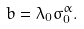Convert formula to latex. <formula><loc_0><loc_0><loc_500><loc_500>b = \lambda _ { 0 } \sigma _ { 0 } ^ { \alpha } .</formula> 